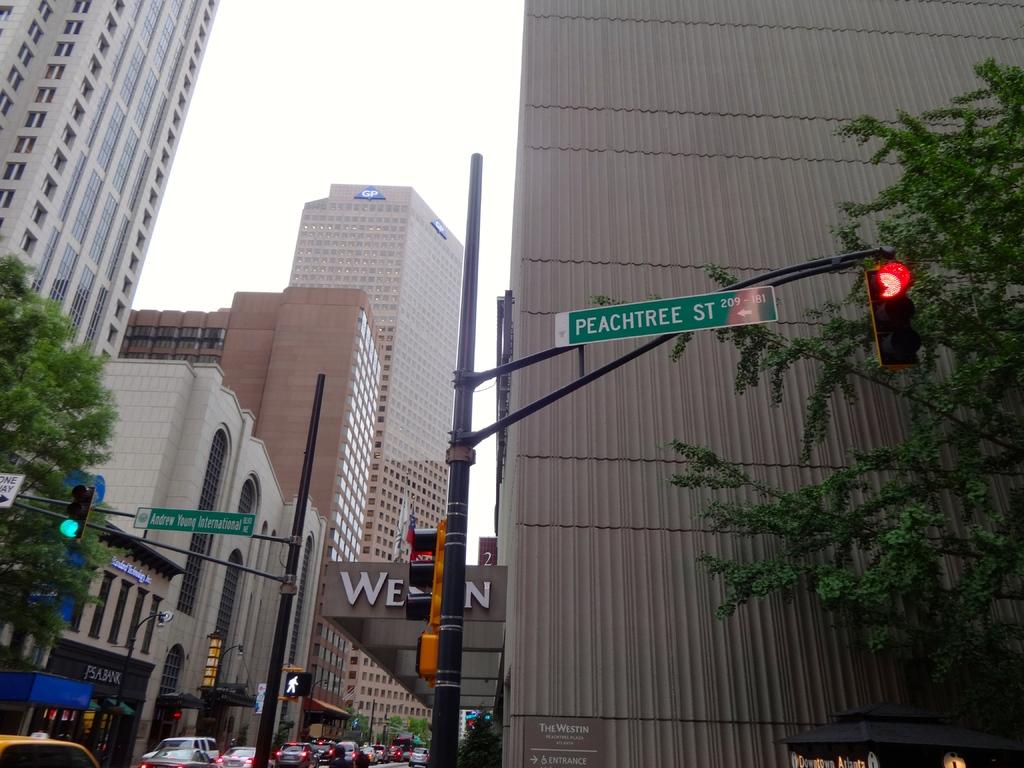What is andrew's last name on the street sign?
Make the answer very short. Young. What is the street sign on the left say?
Offer a very short reply. Andrew young international. 